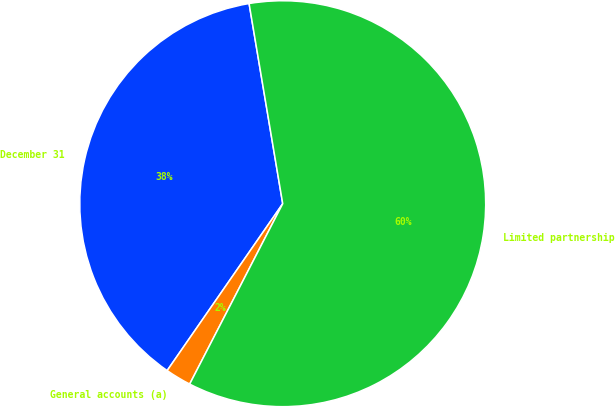<chart> <loc_0><loc_0><loc_500><loc_500><pie_chart><fcel>December 31<fcel>General accounts (a)<fcel>Limited partnership<nl><fcel>37.71%<fcel>2.06%<fcel>60.23%<nl></chart> 